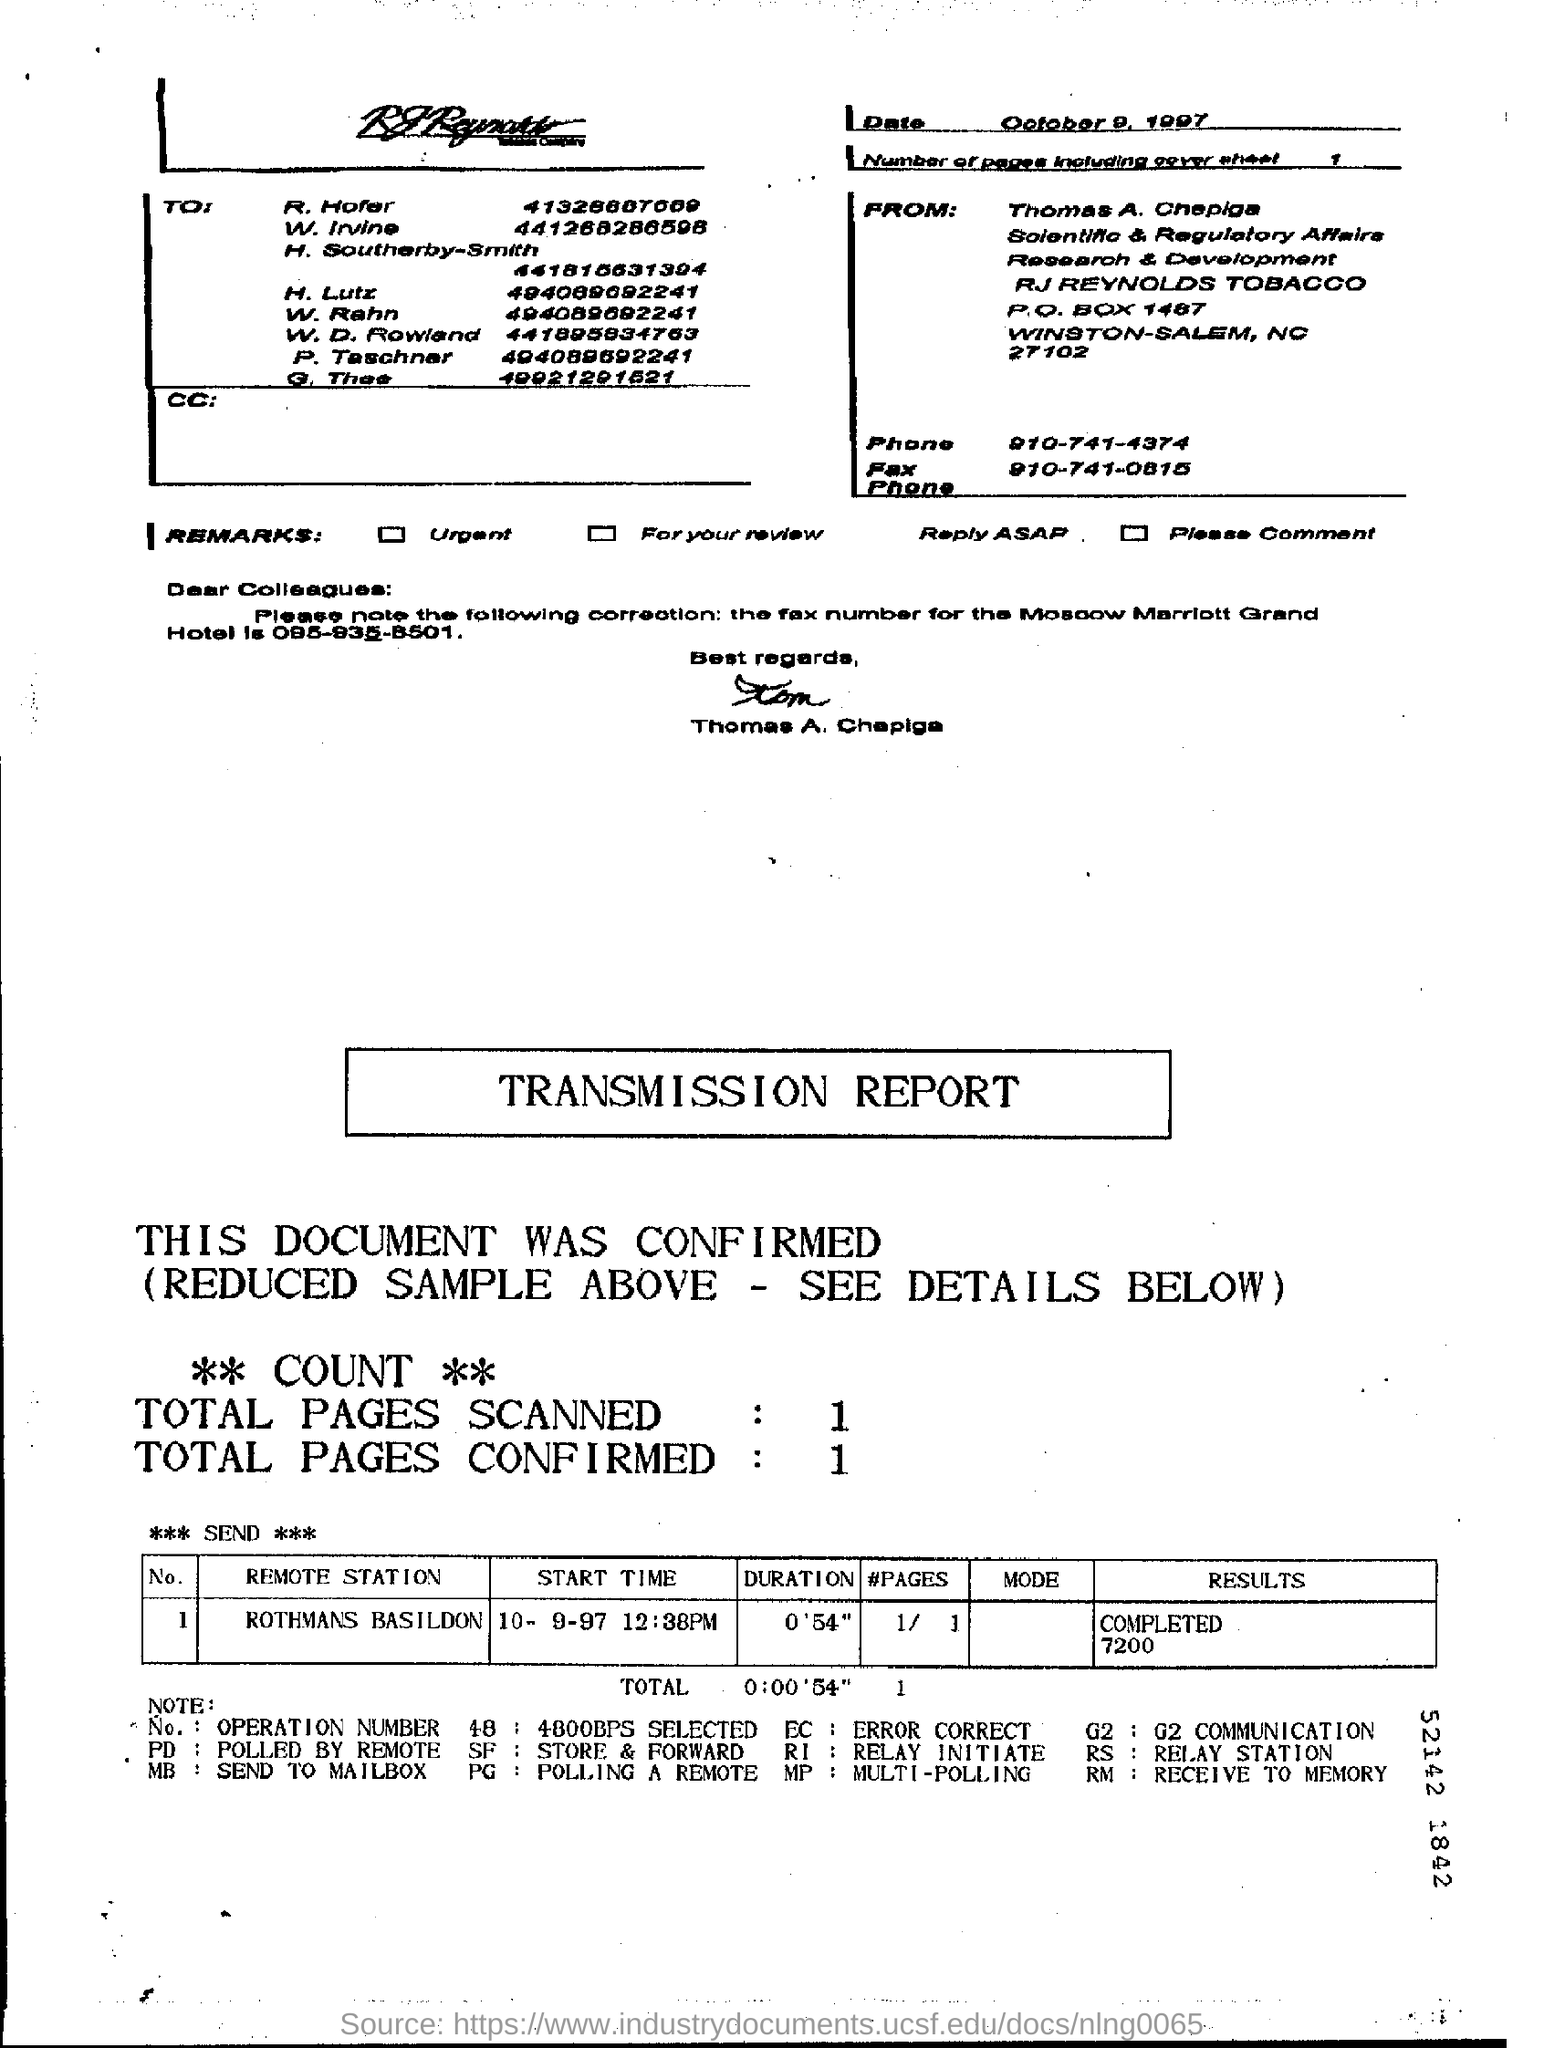How many total pages are scanned ?
Offer a very short reply. 1. What is the corrected fax number for the moscow marriott grand hotel ?
Offer a terse response. 095-935-8501. What is the name of the remote station ?
Your answer should be compact. Rothmans basildon. 